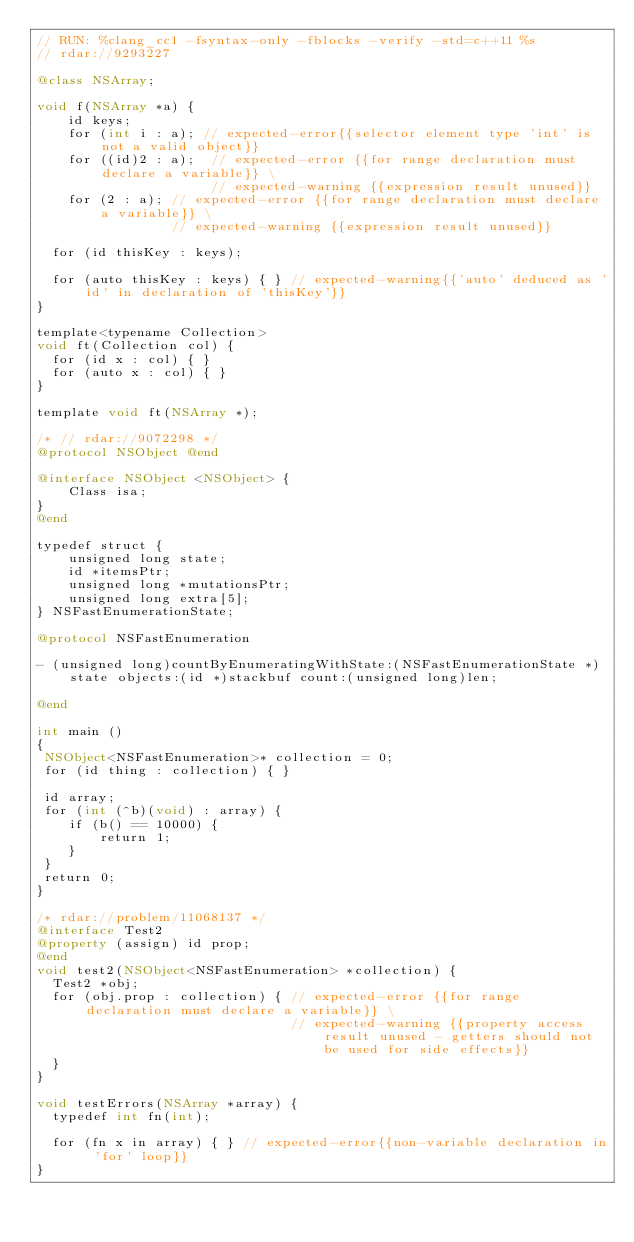<code> <loc_0><loc_0><loc_500><loc_500><_ObjectiveC_>// RUN: %clang_cc1 -fsyntax-only -fblocks -verify -std=c++11 %s
// rdar://9293227

@class NSArray;

void f(NSArray *a) {
    id keys;
    for (int i : a); // expected-error{{selector element type 'int' is not a valid object}} 
    for ((id)2 : a);  // expected-error {{for range declaration must declare a variable}} \
                      // expected-warning {{expression result unused}}
    for (2 : a); // expected-error {{for range declaration must declare a variable}} \
                 // expected-warning {{expression result unused}}
  
  for (id thisKey : keys);

  for (auto thisKey : keys) { } // expected-warning{{'auto' deduced as 'id' in declaration of 'thisKey'}}
}

template<typename Collection>
void ft(Collection col) {
  for (id x : col) { }
  for (auto x : col) { }
}

template void ft(NSArray *);

/* // rdar://9072298 */
@protocol NSObject @end

@interface NSObject <NSObject> {
    Class isa;
}
@end

typedef struct {
    unsigned long state;
    id *itemsPtr;
    unsigned long *mutationsPtr;
    unsigned long extra[5];
} NSFastEnumerationState;

@protocol NSFastEnumeration

- (unsigned long)countByEnumeratingWithState:(NSFastEnumerationState *)state objects:(id *)stackbuf count:(unsigned long)len;

@end

int main ()
{
 NSObject<NSFastEnumeration>* collection = 0;
 for (id thing : collection) { }

 id array;
 for (int (^b)(void) : array) {
    if (b() == 10000) {
        return 1;
    }
 }
 return 0;
}

/* rdar://problem/11068137 */
@interface Test2
@property (assign) id prop;
@end
void test2(NSObject<NSFastEnumeration> *collection) {
  Test2 *obj;
  for (obj.prop : collection) { // expected-error {{for range declaration must declare a variable}} \
                                // expected-warning {{property access result unused - getters should not be used for side effects}}
  }
}

void testErrors(NSArray *array) {
  typedef int fn(int);

  for (fn x in array) { } // expected-error{{non-variable declaration in 'for' loop}}
}
</code> 